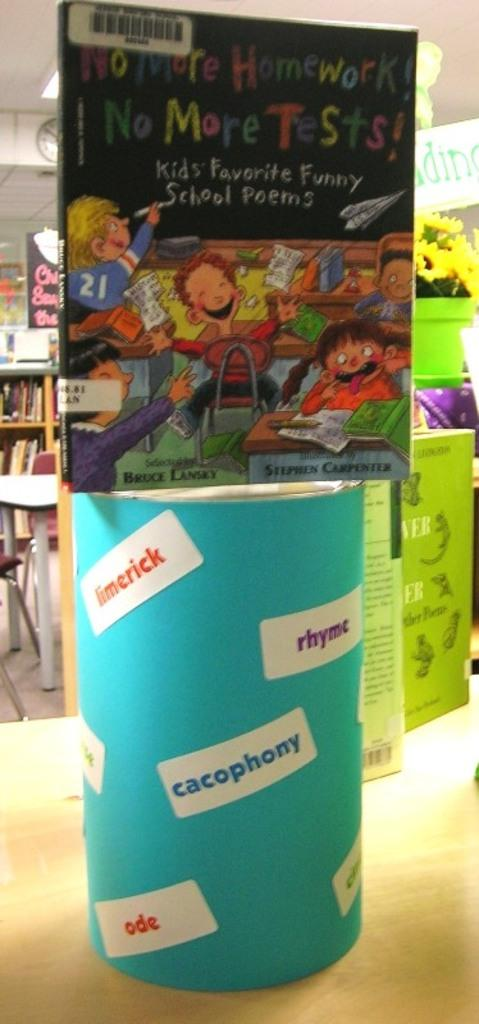<image>
Render a clear and concise summary of the photo. Book for children that is presenting No More Homework, No More Tests and Kids Favorite Funny School Poems. 